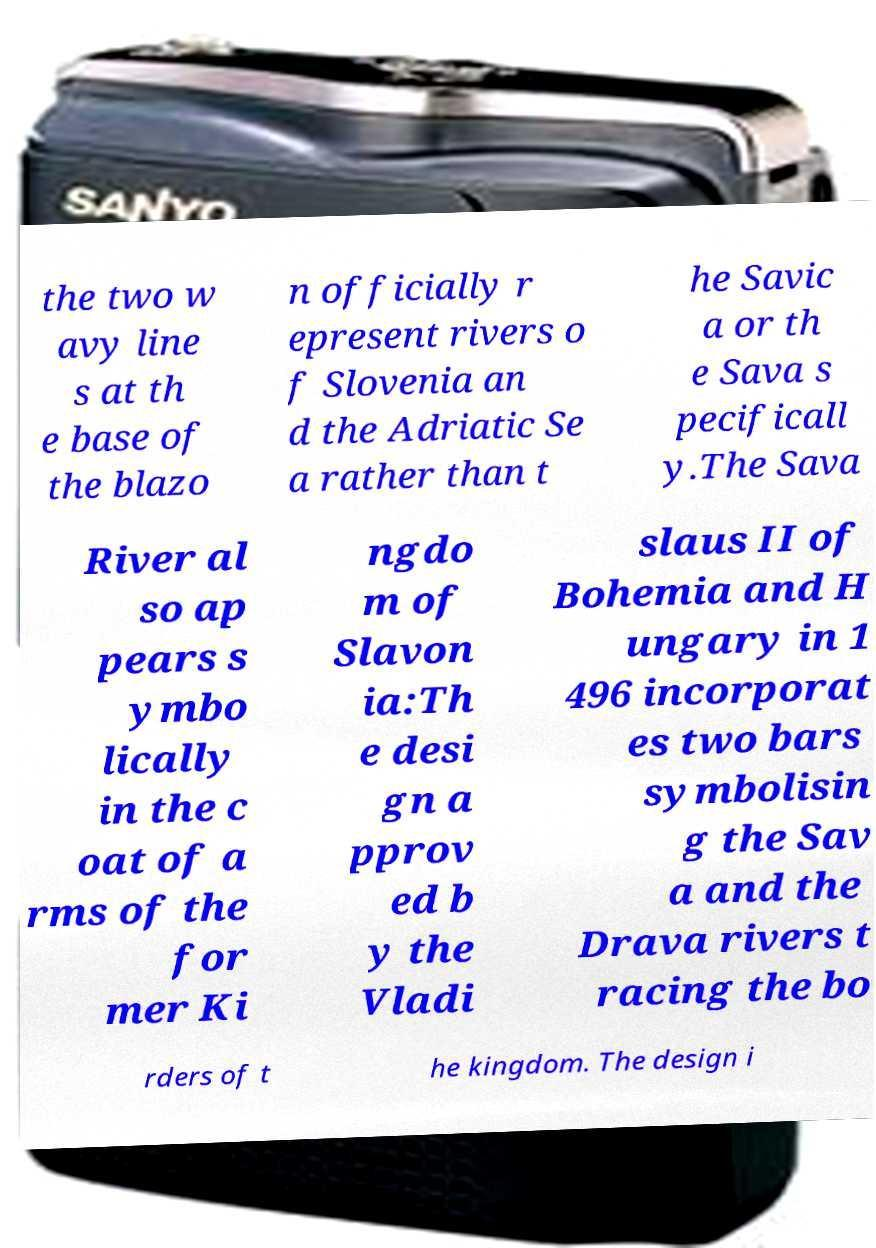Could you extract and type out the text from this image? the two w avy line s at th e base of the blazo n officially r epresent rivers o f Slovenia an d the Adriatic Se a rather than t he Savic a or th e Sava s pecificall y.The Sava River al so ap pears s ymbo lically in the c oat of a rms of the for mer Ki ngdo m of Slavon ia:Th e desi gn a pprov ed b y the Vladi slaus II of Bohemia and H ungary in 1 496 incorporat es two bars symbolisin g the Sav a and the Drava rivers t racing the bo rders of t he kingdom. The design i 